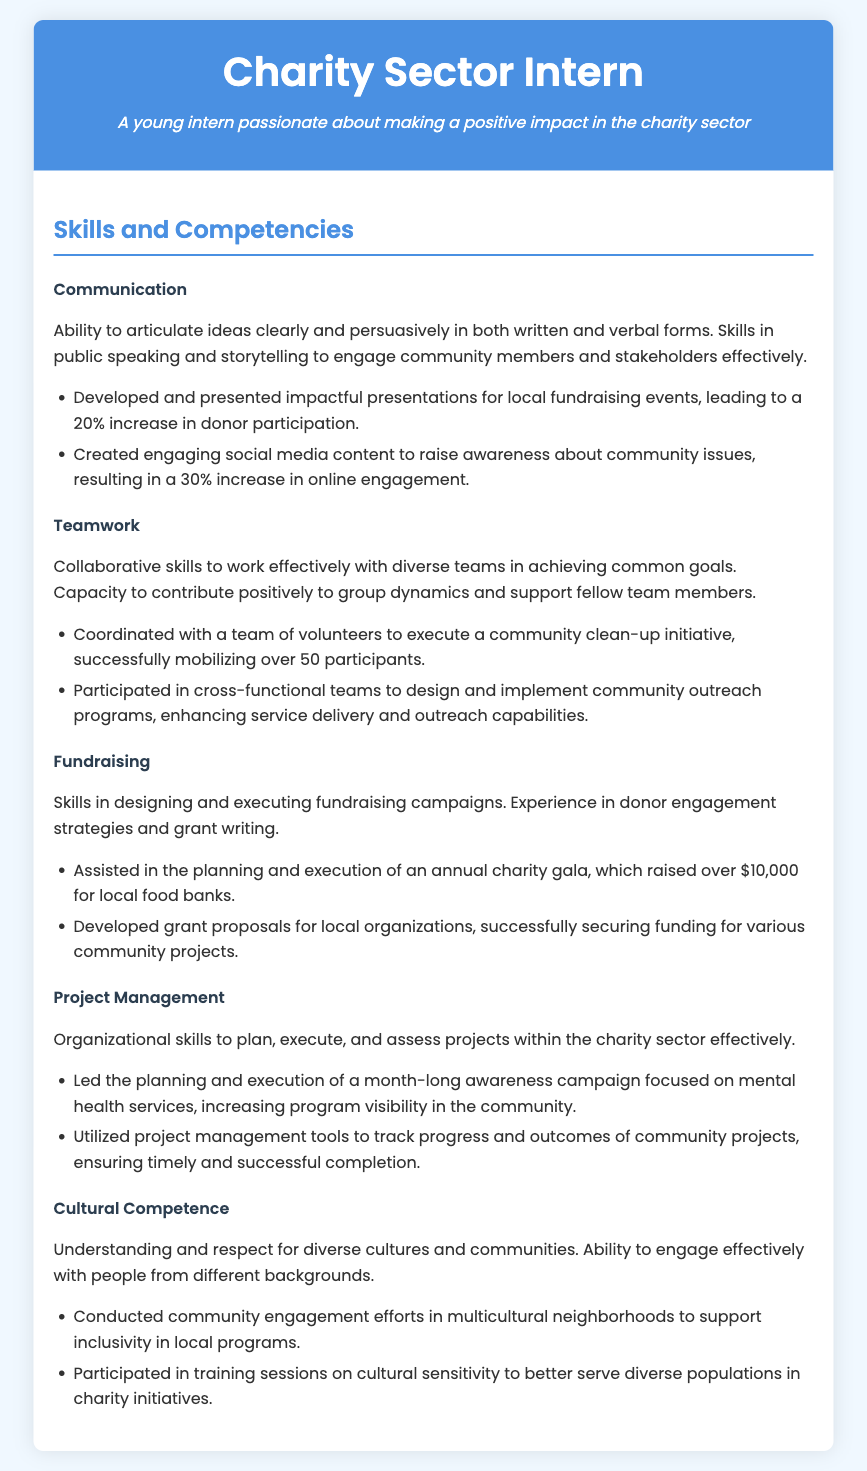what is the title of the document? The title of the document is presented in the header section, indicating the role of the individual.
Answer: Charity Sector Intern what is one skill related to communication? Skills specific to communication describe abilities to engage others; one example is provided in the communication section.
Answer: Public speaking how much money was raised by the annual charity gala? The document explains fundraising efforts, including the amount raised during a specific event.
Answer: $10,000 how many participants were mobilized for the community clean-up initiative? The teamwork section highlights a successful initiative and the number of participants involved.
Answer: 50 which skill involves the ability to understand and respect diverse cultures? The document outlines various competencies, one of which focuses on cultural awareness.
Answer: Cultural Competence what percentage increase in donor participation resulted from the presentations? The communication achievements indicate a measurable outcome from efforts in this area.
Answer: 20% what tools were utilized to track progress in community projects? The project management section mentions specific tools used for effective project oversight.
Answer: Project management tools how many community engagement efforts were conducted in multicultural neighborhoods? The cultural competence section details activities related to engagement, though the document does not specify the number.
Answer: Not specified what was the outcome of the social media content created? The communication section mentions a quantitative result of social media efforts.
Answer: 30% increase in online engagement 